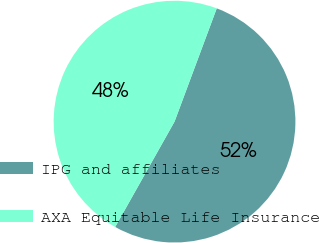<chart> <loc_0><loc_0><loc_500><loc_500><pie_chart><fcel>IPG and affiliates<fcel>AXA Equitable Life Insurance<nl><fcel>52.49%<fcel>47.51%<nl></chart> 